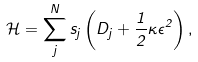Convert formula to latex. <formula><loc_0><loc_0><loc_500><loc_500>\mathcal { H } = \sum _ { j } ^ { N } s _ { j } \left ( D _ { j } + \frac { 1 } { 2 } \kappa \epsilon ^ { 2 } \right ) ,</formula> 